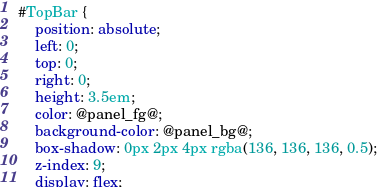Convert code to text. <code><loc_0><loc_0><loc_500><loc_500><_CSS_>#TopBar {
    position: absolute;
    left: 0;
    top: 0;
    right: 0;
    height: 3.5em;
    color: @panel_fg@;
    background-color: @panel_bg@;
    box-shadow: 0px 2px 4px rgba(136, 136, 136, 0.5);
    z-index: 9;
    display: flex;</code> 